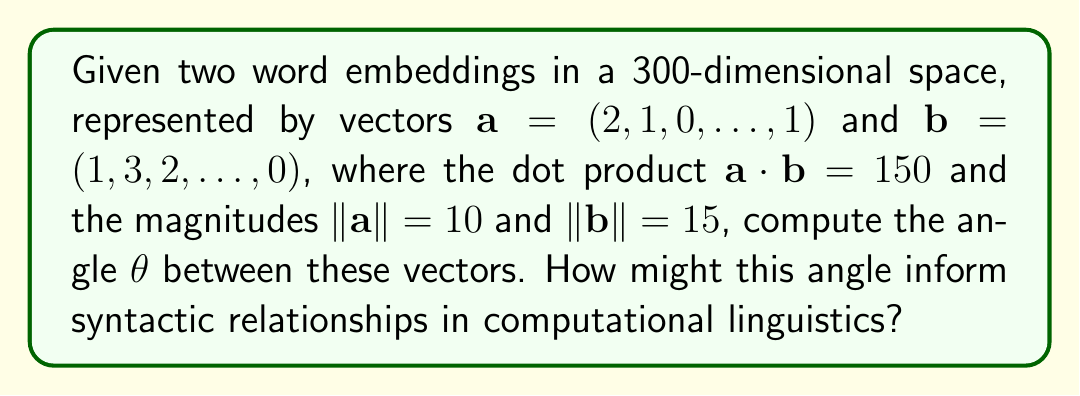Help me with this question. To find the angle between two vectors in a high-dimensional space, we can use the cosine similarity formula:

$$\cos \theta = \frac{\mathbf{a} \cdot \mathbf{b}}{\|\mathbf{a}\| \|\mathbf{b}\|}$$

We are given:
- $\mathbf{a} \cdot \mathbf{b} = 150$
- $\|\mathbf{a}\| = 10$
- $\|\mathbf{b}\| = 15$

Let's substitute these values into the formula:

$$\cos \theta = \frac{150}{10 \cdot 15} = \frac{150}{150} = 1$$

Now, we need to find $\theta$ by taking the inverse cosine (arccos) of both sides:

$$\theta = \arccos(1)$$

The inverse cosine of 1 is 0 radians or 0 degrees.

In the context of computational linguistics and syntax-based theories, this result suggests that the two word embeddings are perfectly aligned in the high-dimensional space. This could indicate that the words represented by these vectors have very similar syntactic roles or distributions in the corpus used to train the embeddings. Such alignment might be observed for words with similar parts of speech or syntactic functions, supporting the idea that distributional patterns in language reflect underlying syntactic structures.
Answer: $\theta = 0^\circ$ 